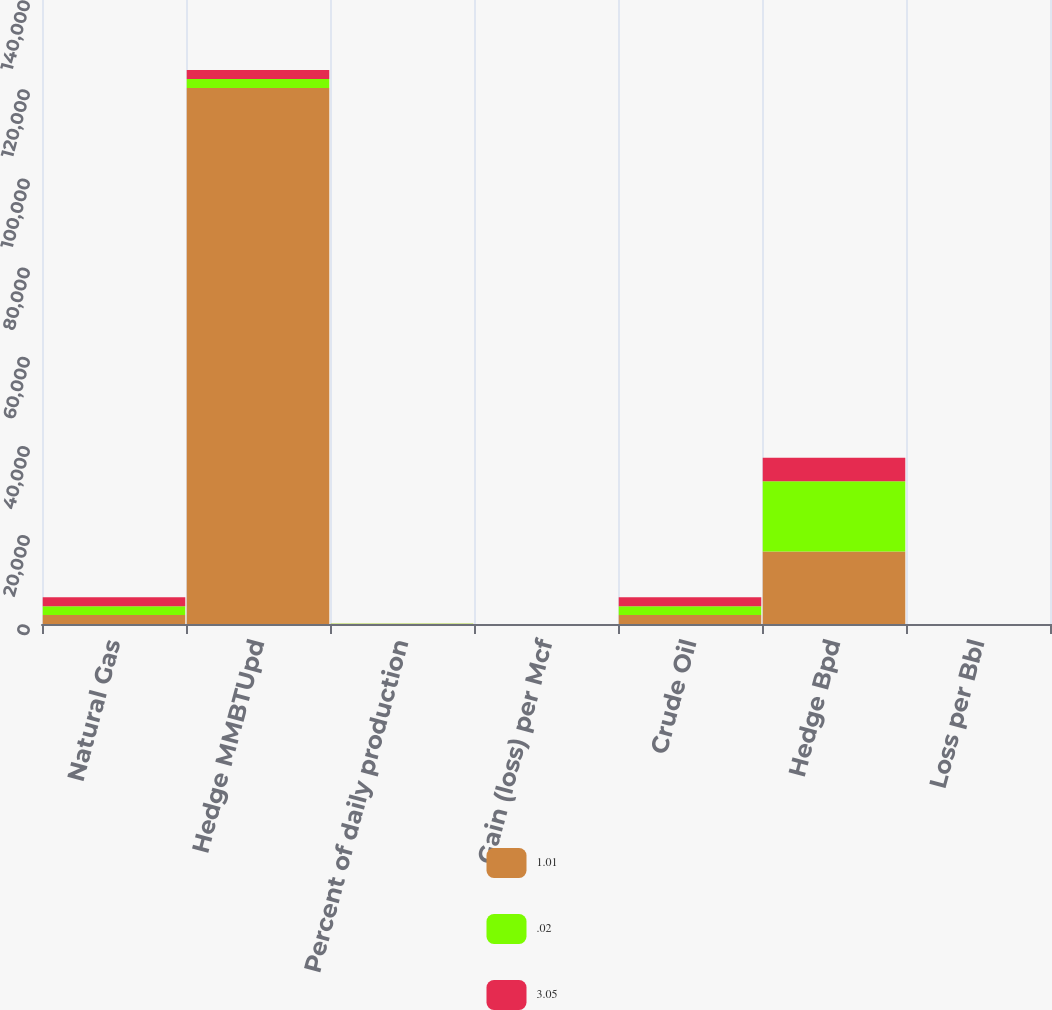Convert chart to OTSL. <chart><loc_0><loc_0><loc_500><loc_500><stacked_bar_chart><ecel><fcel>Natural Gas<fcel>Hedge MMBTUpd<fcel>Percent of daily production<fcel>Gain (loss) per Mcf<fcel>Crude Oil<fcel>Hedge Bpd<fcel>Loss per Bbl<nl><fcel>1.01<fcel>2004<fcel>120284<fcel>33<fcel>0.08<fcel>2004<fcel>16261<fcel>3.05<nl><fcel>0.02<fcel>2003<fcel>2002<fcel>56<fcel>0.44<fcel>2003<fcel>15793<fcel>1.01<nl><fcel>3.05<fcel>2002<fcel>2002<fcel>50<fcel>0.05<fcel>2002<fcel>5247<fcel>0.02<nl></chart> 